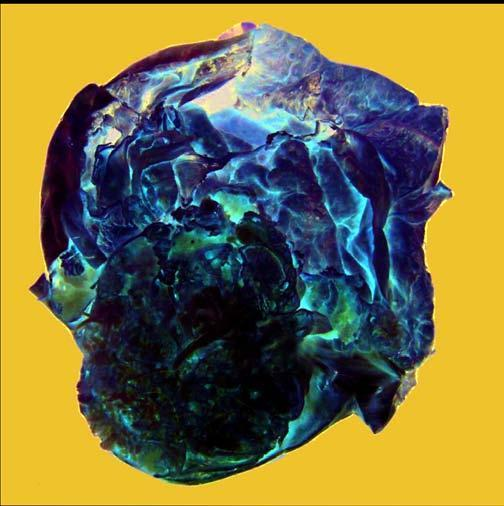does the cyst wall show presence of loculi containing gelatinous mucoid material?
Answer the question using a single word or phrase. Yes 